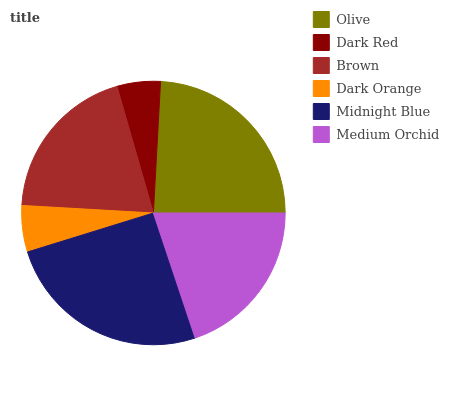Is Dark Red the minimum?
Answer yes or no. Yes. Is Midnight Blue the maximum?
Answer yes or no. Yes. Is Brown the minimum?
Answer yes or no. No. Is Brown the maximum?
Answer yes or no. No. Is Brown greater than Dark Red?
Answer yes or no. Yes. Is Dark Red less than Brown?
Answer yes or no. Yes. Is Dark Red greater than Brown?
Answer yes or no. No. Is Brown less than Dark Red?
Answer yes or no. No. Is Medium Orchid the high median?
Answer yes or no. Yes. Is Brown the low median?
Answer yes or no. Yes. Is Olive the high median?
Answer yes or no. No. Is Olive the low median?
Answer yes or no. No. 